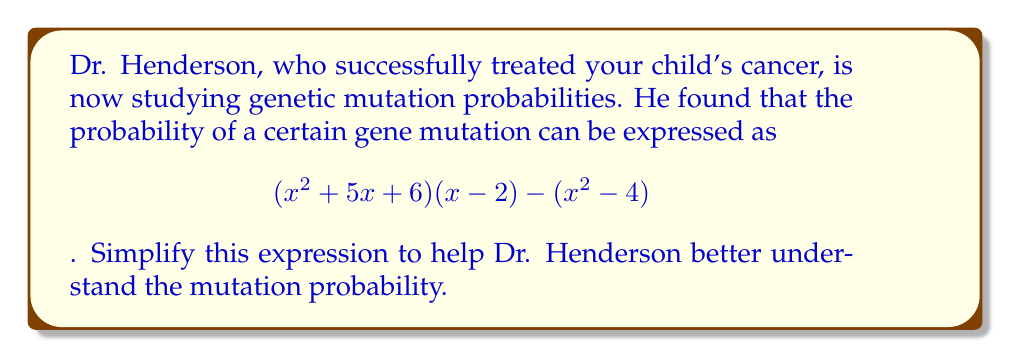Can you solve this math problem? Let's simplify this expression step by step:

1) First, let's expand $(x^2 + 5x + 6)(x - 2)$:
   $$(x^2 + 5x + 6)(x - 2) = x^3 + 5x^2 + 6x - 2x^2 - 10x - 12$$
   $$= x^3 + 3x^2 - 4x - 12$$

2) Now our expression looks like:
   $$(x^3 + 3x^2 - 4x - 12) - (x^2 - 4)$$

3) Let's subtract $x^2 - 4$ from the first part:
   $$x^3 + 3x^2 - 4x - 12 - x^2 + 4$$
   $$= x^3 + 2x^2 - 4x - 8$$

4) This is our simplified expression. We can factor out an $x$ to get:
   $$x(x^2 + 2x - 4) - 8$$

5) The quadratic expression inside the parentheses can be factored:
   $$x(x + 4)(x - 2) - 8$$

This is the most simplified form of the expression.
Answer: $$x(x + 4)(x - 2) - 8$$ 